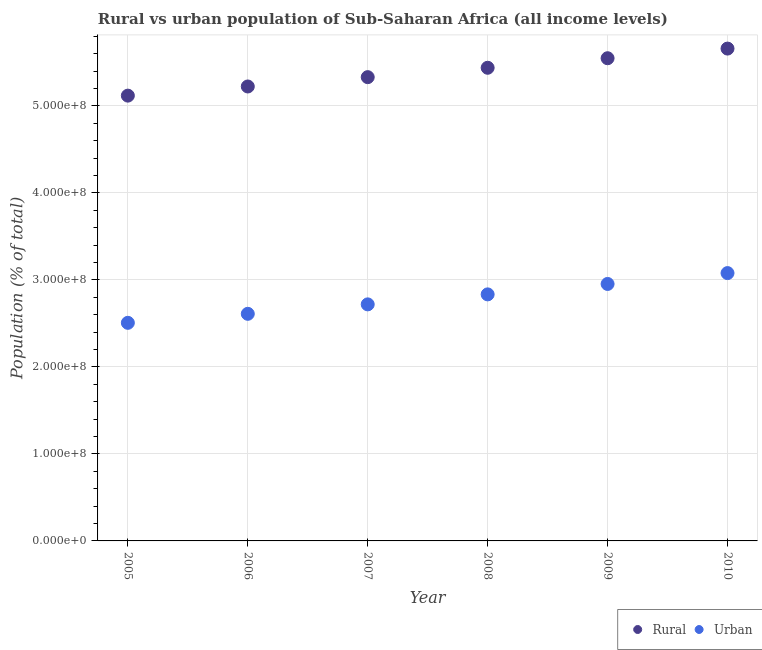How many different coloured dotlines are there?
Provide a short and direct response. 2. Is the number of dotlines equal to the number of legend labels?
Offer a very short reply. Yes. What is the rural population density in 2009?
Ensure brevity in your answer.  5.55e+08. Across all years, what is the maximum urban population density?
Ensure brevity in your answer.  3.08e+08. Across all years, what is the minimum rural population density?
Make the answer very short. 5.12e+08. In which year was the urban population density maximum?
Provide a short and direct response. 2010. In which year was the urban population density minimum?
Your response must be concise. 2005. What is the total urban population density in the graph?
Your answer should be compact. 1.67e+09. What is the difference between the rural population density in 2007 and that in 2009?
Ensure brevity in your answer.  -2.17e+07. What is the difference between the urban population density in 2010 and the rural population density in 2008?
Make the answer very short. -2.36e+08. What is the average urban population density per year?
Make the answer very short. 2.78e+08. In the year 2007, what is the difference between the rural population density and urban population density?
Your answer should be very brief. 2.61e+08. In how many years, is the urban population density greater than 240000000 %?
Offer a terse response. 6. What is the ratio of the rural population density in 2007 to that in 2010?
Give a very brief answer. 0.94. Is the difference between the urban population density in 2006 and 2007 greater than the difference between the rural population density in 2006 and 2007?
Offer a terse response. No. What is the difference between the highest and the second highest rural population density?
Your answer should be compact. 1.11e+07. What is the difference between the highest and the lowest rural population density?
Offer a terse response. 5.41e+07. In how many years, is the rural population density greater than the average rural population density taken over all years?
Your response must be concise. 3. Is the sum of the urban population density in 2008 and 2009 greater than the maximum rural population density across all years?
Your response must be concise. Yes. Does the urban population density monotonically increase over the years?
Keep it short and to the point. Yes. Is the rural population density strictly greater than the urban population density over the years?
Your answer should be very brief. Yes. How many dotlines are there?
Make the answer very short. 2. Where does the legend appear in the graph?
Keep it short and to the point. Bottom right. How many legend labels are there?
Your response must be concise. 2. How are the legend labels stacked?
Ensure brevity in your answer.  Horizontal. What is the title of the graph?
Make the answer very short. Rural vs urban population of Sub-Saharan Africa (all income levels). What is the label or title of the X-axis?
Give a very brief answer. Year. What is the label or title of the Y-axis?
Make the answer very short. Population (% of total). What is the Population (% of total) of Rural in 2005?
Provide a short and direct response. 5.12e+08. What is the Population (% of total) in Urban in 2005?
Your answer should be very brief. 2.51e+08. What is the Population (% of total) in Rural in 2006?
Your response must be concise. 5.22e+08. What is the Population (% of total) of Urban in 2006?
Your response must be concise. 2.61e+08. What is the Population (% of total) in Rural in 2007?
Provide a short and direct response. 5.33e+08. What is the Population (% of total) in Urban in 2007?
Keep it short and to the point. 2.72e+08. What is the Population (% of total) of Rural in 2008?
Offer a terse response. 5.44e+08. What is the Population (% of total) in Urban in 2008?
Make the answer very short. 2.83e+08. What is the Population (% of total) in Rural in 2009?
Offer a terse response. 5.55e+08. What is the Population (% of total) in Urban in 2009?
Offer a terse response. 2.95e+08. What is the Population (% of total) of Rural in 2010?
Your answer should be very brief. 5.66e+08. What is the Population (% of total) in Urban in 2010?
Offer a very short reply. 3.08e+08. Across all years, what is the maximum Population (% of total) of Rural?
Offer a terse response. 5.66e+08. Across all years, what is the maximum Population (% of total) of Urban?
Your response must be concise. 3.08e+08. Across all years, what is the minimum Population (% of total) in Rural?
Make the answer very short. 5.12e+08. Across all years, what is the minimum Population (% of total) of Urban?
Make the answer very short. 2.51e+08. What is the total Population (% of total) of Rural in the graph?
Keep it short and to the point. 3.23e+09. What is the total Population (% of total) of Urban in the graph?
Keep it short and to the point. 1.67e+09. What is the difference between the Population (% of total) in Rural in 2005 and that in 2006?
Your answer should be very brief. -1.05e+07. What is the difference between the Population (% of total) in Urban in 2005 and that in 2006?
Offer a terse response. -1.04e+07. What is the difference between the Population (% of total) in Rural in 2005 and that in 2007?
Your answer should be very brief. -2.12e+07. What is the difference between the Population (% of total) in Urban in 2005 and that in 2007?
Your answer should be very brief. -2.12e+07. What is the difference between the Population (% of total) in Rural in 2005 and that in 2008?
Make the answer very short. -3.20e+07. What is the difference between the Population (% of total) in Urban in 2005 and that in 2008?
Offer a terse response. -3.27e+07. What is the difference between the Population (% of total) of Rural in 2005 and that in 2009?
Offer a terse response. -4.30e+07. What is the difference between the Population (% of total) of Urban in 2005 and that in 2009?
Your response must be concise. -4.47e+07. What is the difference between the Population (% of total) of Rural in 2005 and that in 2010?
Your response must be concise. -5.41e+07. What is the difference between the Population (% of total) of Urban in 2005 and that in 2010?
Your answer should be compact. -5.72e+07. What is the difference between the Population (% of total) in Rural in 2006 and that in 2007?
Give a very brief answer. -1.07e+07. What is the difference between the Population (% of total) of Urban in 2006 and that in 2007?
Ensure brevity in your answer.  -1.09e+07. What is the difference between the Population (% of total) in Rural in 2006 and that in 2008?
Keep it short and to the point. -2.15e+07. What is the difference between the Population (% of total) of Urban in 2006 and that in 2008?
Your answer should be very brief. -2.23e+07. What is the difference between the Population (% of total) of Rural in 2006 and that in 2009?
Ensure brevity in your answer.  -3.25e+07. What is the difference between the Population (% of total) of Urban in 2006 and that in 2009?
Provide a succinct answer. -3.43e+07. What is the difference between the Population (% of total) of Rural in 2006 and that in 2010?
Keep it short and to the point. -4.36e+07. What is the difference between the Population (% of total) in Urban in 2006 and that in 2010?
Make the answer very short. -4.68e+07. What is the difference between the Population (% of total) of Rural in 2007 and that in 2008?
Make the answer very short. -1.08e+07. What is the difference between the Population (% of total) of Urban in 2007 and that in 2008?
Make the answer very short. -1.15e+07. What is the difference between the Population (% of total) of Rural in 2007 and that in 2009?
Give a very brief answer. -2.17e+07. What is the difference between the Population (% of total) of Urban in 2007 and that in 2009?
Offer a terse response. -2.35e+07. What is the difference between the Population (% of total) in Rural in 2007 and that in 2010?
Provide a succinct answer. -3.28e+07. What is the difference between the Population (% of total) in Urban in 2007 and that in 2010?
Provide a short and direct response. -3.60e+07. What is the difference between the Population (% of total) of Rural in 2008 and that in 2009?
Make the answer very short. -1.10e+07. What is the difference between the Population (% of total) in Urban in 2008 and that in 2009?
Keep it short and to the point. -1.20e+07. What is the difference between the Population (% of total) in Rural in 2008 and that in 2010?
Give a very brief answer. -2.20e+07. What is the difference between the Population (% of total) of Urban in 2008 and that in 2010?
Make the answer very short. -2.45e+07. What is the difference between the Population (% of total) in Rural in 2009 and that in 2010?
Offer a terse response. -1.11e+07. What is the difference between the Population (% of total) in Urban in 2009 and that in 2010?
Offer a very short reply. -1.25e+07. What is the difference between the Population (% of total) of Rural in 2005 and the Population (% of total) of Urban in 2006?
Make the answer very short. 2.51e+08. What is the difference between the Population (% of total) of Rural in 2005 and the Population (% of total) of Urban in 2007?
Offer a terse response. 2.40e+08. What is the difference between the Population (% of total) of Rural in 2005 and the Population (% of total) of Urban in 2008?
Ensure brevity in your answer.  2.28e+08. What is the difference between the Population (% of total) in Rural in 2005 and the Population (% of total) in Urban in 2009?
Provide a short and direct response. 2.16e+08. What is the difference between the Population (% of total) of Rural in 2005 and the Population (% of total) of Urban in 2010?
Make the answer very short. 2.04e+08. What is the difference between the Population (% of total) of Rural in 2006 and the Population (% of total) of Urban in 2007?
Provide a succinct answer. 2.50e+08. What is the difference between the Population (% of total) of Rural in 2006 and the Population (% of total) of Urban in 2008?
Give a very brief answer. 2.39e+08. What is the difference between the Population (% of total) in Rural in 2006 and the Population (% of total) in Urban in 2009?
Your answer should be compact. 2.27e+08. What is the difference between the Population (% of total) of Rural in 2006 and the Population (% of total) of Urban in 2010?
Ensure brevity in your answer.  2.15e+08. What is the difference between the Population (% of total) of Rural in 2007 and the Population (% of total) of Urban in 2008?
Make the answer very short. 2.50e+08. What is the difference between the Population (% of total) of Rural in 2007 and the Population (% of total) of Urban in 2009?
Keep it short and to the point. 2.38e+08. What is the difference between the Population (% of total) of Rural in 2007 and the Population (% of total) of Urban in 2010?
Your answer should be compact. 2.25e+08. What is the difference between the Population (% of total) of Rural in 2008 and the Population (% of total) of Urban in 2009?
Make the answer very short. 2.49e+08. What is the difference between the Population (% of total) of Rural in 2008 and the Population (% of total) of Urban in 2010?
Keep it short and to the point. 2.36e+08. What is the difference between the Population (% of total) in Rural in 2009 and the Population (% of total) in Urban in 2010?
Provide a short and direct response. 2.47e+08. What is the average Population (% of total) of Rural per year?
Offer a very short reply. 5.39e+08. What is the average Population (% of total) in Urban per year?
Ensure brevity in your answer.  2.78e+08. In the year 2005, what is the difference between the Population (% of total) of Rural and Population (% of total) of Urban?
Offer a very short reply. 2.61e+08. In the year 2006, what is the difference between the Population (% of total) of Rural and Population (% of total) of Urban?
Keep it short and to the point. 2.61e+08. In the year 2007, what is the difference between the Population (% of total) of Rural and Population (% of total) of Urban?
Offer a terse response. 2.61e+08. In the year 2008, what is the difference between the Population (% of total) of Rural and Population (% of total) of Urban?
Provide a succinct answer. 2.60e+08. In the year 2009, what is the difference between the Population (% of total) in Rural and Population (% of total) in Urban?
Offer a very short reply. 2.59e+08. In the year 2010, what is the difference between the Population (% of total) of Rural and Population (% of total) of Urban?
Provide a short and direct response. 2.58e+08. What is the ratio of the Population (% of total) of Rural in 2005 to that in 2006?
Ensure brevity in your answer.  0.98. What is the ratio of the Population (% of total) in Urban in 2005 to that in 2006?
Your answer should be compact. 0.96. What is the ratio of the Population (% of total) of Rural in 2005 to that in 2007?
Offer a terse response. 0.96. What is the ratio of the Population (% of total) in Urban in 2005 to that in 2007?
Your answer should be compact. 0.92. What is the ratio of the Population (% of total) of Rural in 2005 to that in 2008?
Keep it short and to the point. 0.94. What is the ratio of the Population (% of total) of Urban in 2005 to that in 2008?
Your answer should be very brief. 0.88. What is the ratio of the Population (% of total) in Rural in 2005 to that in 2009?
Ensure brevity in your answer.  0.92. What is the ratio of the Population (% of total) of Urban in 2005 to that in 2009?
Offer a very short reply. 0.85. What is the ratio of the Population (% of total) in Rural in 2005 to that in 2010?
Provide a succinct answer. 0.9. What is the ratio of the Population (% of total) in Urban in 2005 to that in 2010?
Provide a succinct answer. 0.81. What is the ratio of the Population (% of total) of Rural in 2006 to that in 2007?
Provide a short and direct response. 0.98. What is the ratio of the Population (% of total) of Urban in 2006 to that in 2007?
Provide a short and direct response. 0.96. What is the ratio of the Population (% of total) in Rural in 2006 to that in 2008?
Offer a terse response. 0.96. What is the ratio of the Population (% of total) in Urban in 2006 to that in 2008?
Offer a terse response. 0.92. What is the ratio of the Population (% of total) in Rural in 2006 to that in 2009?
Ensure brevity in your answer.  0.94. What is the ratio of the Population (% of total) of Urban in 2006 to that in 2009?
Ensure brevity in your answer.  0.88. What is the ratio of the Population (% of total) in Rural in 2006 to that in 2010?
Ensure brevity in your answer.  0.92. What is the ratio of the Population (% of total) in Urban in 2006 to that in 2010?
Offer a very short reply. 0.85. What is the ratio of the Population (% of total) in Rural in 2007 to that in 2008?
Offer a terse response. 0.98. What is the ratio of the Population (% of total) in Urban in 2007 to that in 2008?
Ensure brevity in your answer.  0.96. What is the ratio of the Population (% of total) of Rural in 2007 to that in 2009?
Provide a short and direct response. 0.96. What is the ratio of the Population (% of total) of Urban in 2007 to that in 2009?
Your answer should be compact. 0.92. What is the ratio of the Population (% of total) of Rural in 2007 to that in 2010?
Your response must be concise. 0.94. What is the ratio of the Population (% of total) in Urban in 2007 to that in 2010?
Your response must be concise. 0.88. What is the ratio of the Population (% of total) in Rural in 2008 to that in 2009?
Provide a succinct answer. 0.98. What is the ratio of the Population (% of total) of Urban in 2008 to that in 2009?
Your answer should be very brief. 0.96. What is the ratio of the Population (% of total) of Rural in 2008 to that in 2010?
Your answer should be very brief. 0.96. What is the ratio of the Population (% of total) of Urban in 2008 to that in 2010?
Your answer should be very brief. 0.92. What is the ratio of the Population (% of total) of Rural in 2009 to that in 2010?
Make the answer very short. 0.98. What is the ratio of the Population (% of total) in Urban in 2009 to that in 2010?
Provide a succinct answer. 0.96. What is the difference between the highest and the second highest Population (% of total) of Rural?
Offer a very short reply. 1.11e+07. What is the difference between the highest and the second highest Population (% of total) in Urban?
Ensure brevity in your answer.  1.25e+07. What is the difference between the highest and the lowest Population (% of total) in Rural?
Provide a short and direct response. 5.41e+07. What is the difference between the highest and the lowest Population (% of total) in Urban?
Your answer should be compact. 5.72e+07. 